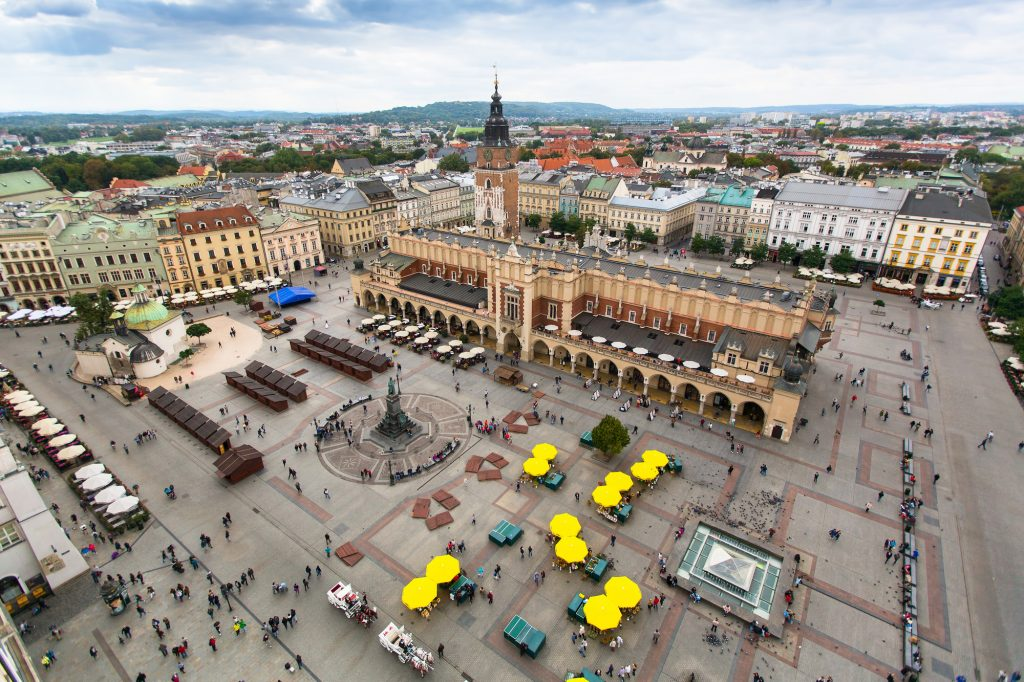Can you elaborate on the elements of the picture provided? The image presents a vibrant aerial view of the Main Market Square in Krakow, Poland, one of Europe's largest medieval squares. This bustling area is shown filled with people and lined with yellow umbrellas that bring a burst of color to the predominantly beige and green scenery. The architecture surrounding the square features traditional European designs with historical facades that reflect Krakow's rich past. At the heart of the square stands the iconic Cloth Hall, known for its role in Krakow’s trading history. Meanwhile, the Gothic towers of St. Mary's Basilica dominate the background, serving both as a religious symbol and a prominent navigation point in the city. The image not only captures the architectural beauty and historical depth of Krakow but also its current vibrancy and the daily life of its inhabitants. 